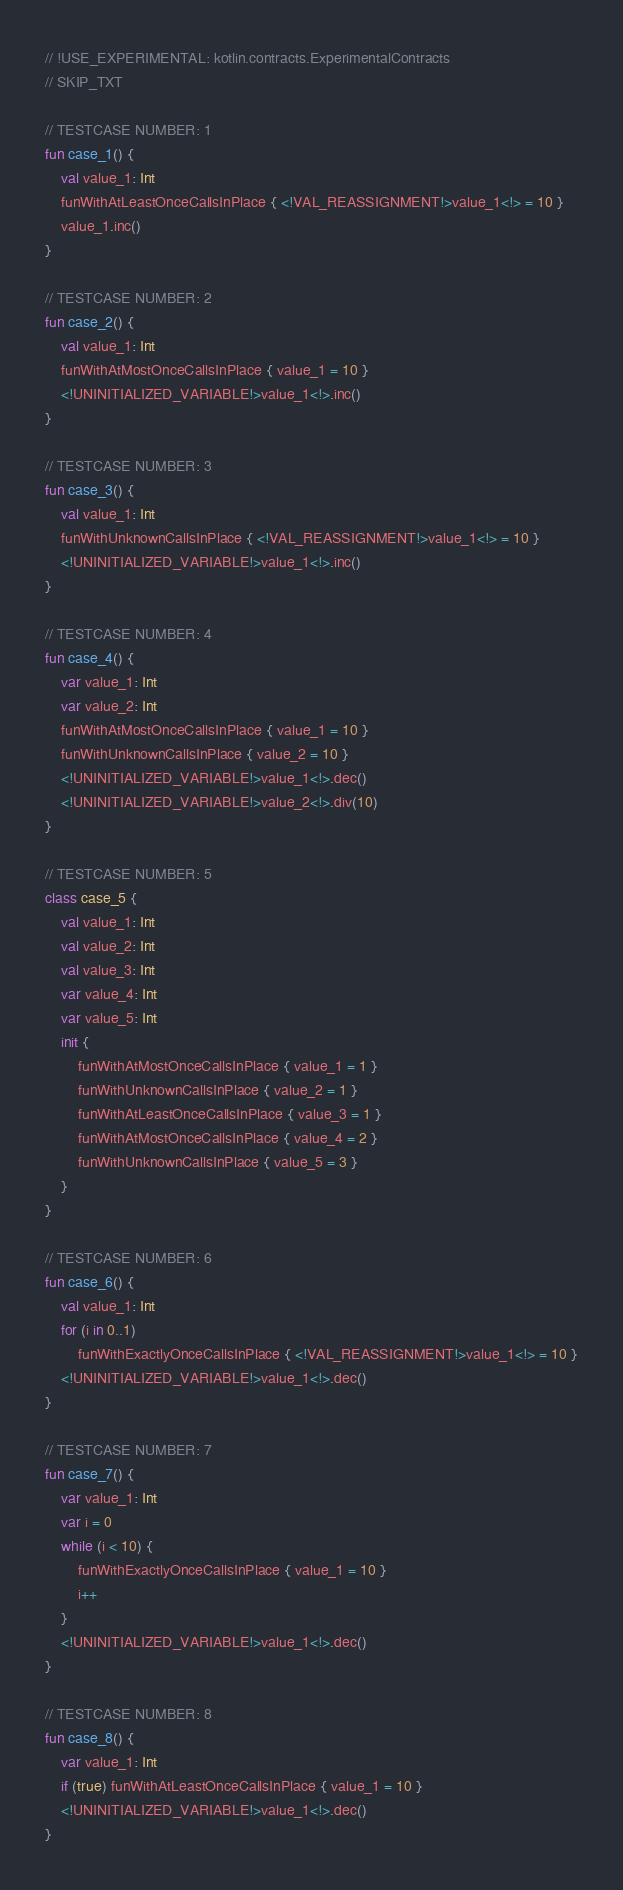Convert code to text. <code><loc_0><loc_0><loc_500><loc_500><_Kotlin_>// !USE_EXPERIMENTAL: kotlin.contracts.ExperimentalContracts
// SKIP_TXT

// TESTCASE NUMBER: 1
fun case_1() {
    val value_1: Int
    funWithAtLeastOnceCallsInPlace { <!VAL_REASSIGNMENT!>value_1<!> = 10 }
    value_1.inc()
}

// TESTCASE NUMBER: 2
fun case_2() {
    val value_1: Int
    funWithAtMostOnceCallsInPlace { value_1 = 10 }
    <!UNINITIALIZED_VARIABLE!>value_1<!>.inc()
}

// TESTCASE NUMBER: 3
fun case_3() {
    val value_1: Int
    funWithUnknownCallsInPlace { <!VAL_REASSIGNMENT!>value_1<!> = 10 }
    <!UNINITIALIZED_VARIABLE!>value_1<!>.inc()
}

// TESTCASE NUMBER: 4
fun case_4() {
    var value_1: Int
    var value_2: Int
    funWithAtMostOnceCallsInPlace { value_1 = 10 }
    funWithUnknownCallsInPlace { value_2 = 10 }
    <!UNINITIALIZED_VARIABLE!>value_1<!>.dec()
    <!UNINITIALIZED_VARIABLE!>value_2<!>.div(10)
}

// TESTCASE NUMBER: 5
class case_5 {
    val value_1: Int
    val value_2: Int
    val value_3: Int
    var value_4: Int
    var value_5: Int
    init {
        funWithAtMostOnceCallsInPlace { value_1 = 1 }
        funWithUnknownCallsInPlace { value_2 = 1 }
        funWithAtLeastOnceCallsInPlace { value_3 = 1 }
        funWithAtMostOnceCallsInPlace { value_4 = 2 }
        funWithUnknownCallsInPlace { value_5 = 3 }
    }
}

// TESTCASE NUMBER: 6
fun case_6() {
    val value_1: Int
    for (i in 0..1)
        funWithExactlyOnceCallsInPlace { <!VAL_REASSIGNMENT!>value_1<!> = 10 }
    <!UNINITIALIZED_VARIABLE!>value_1<!>.dec()
}

// TESTCASE NUMBER: 7
fun case_7() {
    var value_1: Int
    var i = 0
    while (i < 10) {
        funWithExactlyOnceCallsInPlace { value_1 = 10 }
        i++
    }
    <!UNINITIALIZED_VARIABLE!>value_1<!>.dec()
}

// TESTCASE NUMBER: 8
fun case_8() {
    var value_1: Int
    if (true) funWithAtLeastOnceCallsInPlace { value_1 = 10 }
    <!UNINITIALIZED_VARIABLE!>value_1<!>.dec()
}
</code> 